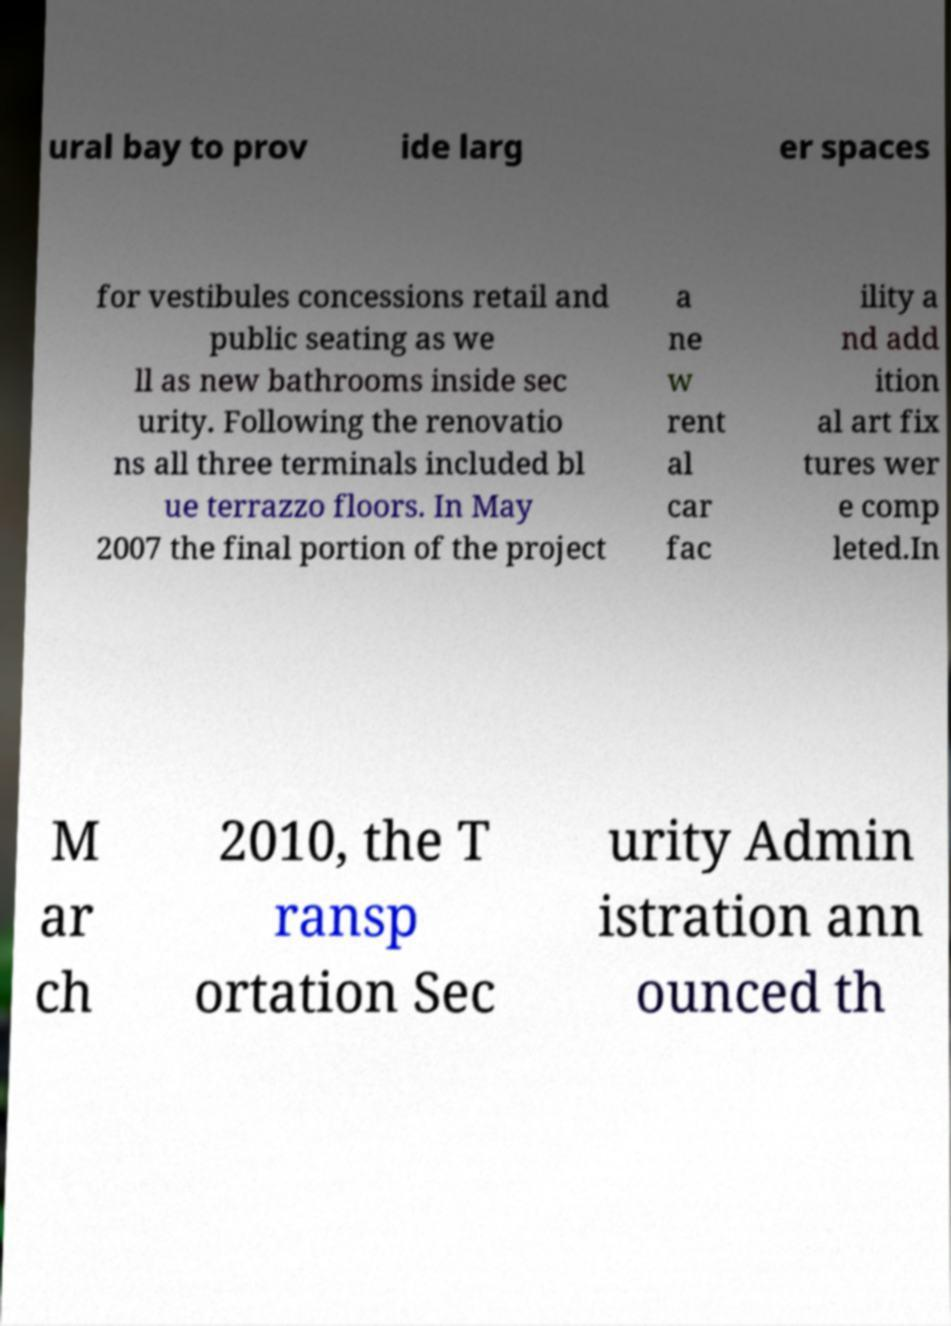Can you accurately transcribe the text from the provided image for me? ural bay to prov ide larg er spaces for vestibules concessions retail and public seating as we ll as new bathrooms inside sec urity. Following the renovatio ns all three terminals included bl ue terrazzo floors. In May 2007 the final portion of the project a ne w rent al car fac ility a nd add ition al art fix tures wer e comp leted.In M ar ch 2010, the T ransp ortation Sec urity Admin istration ann ounced th 